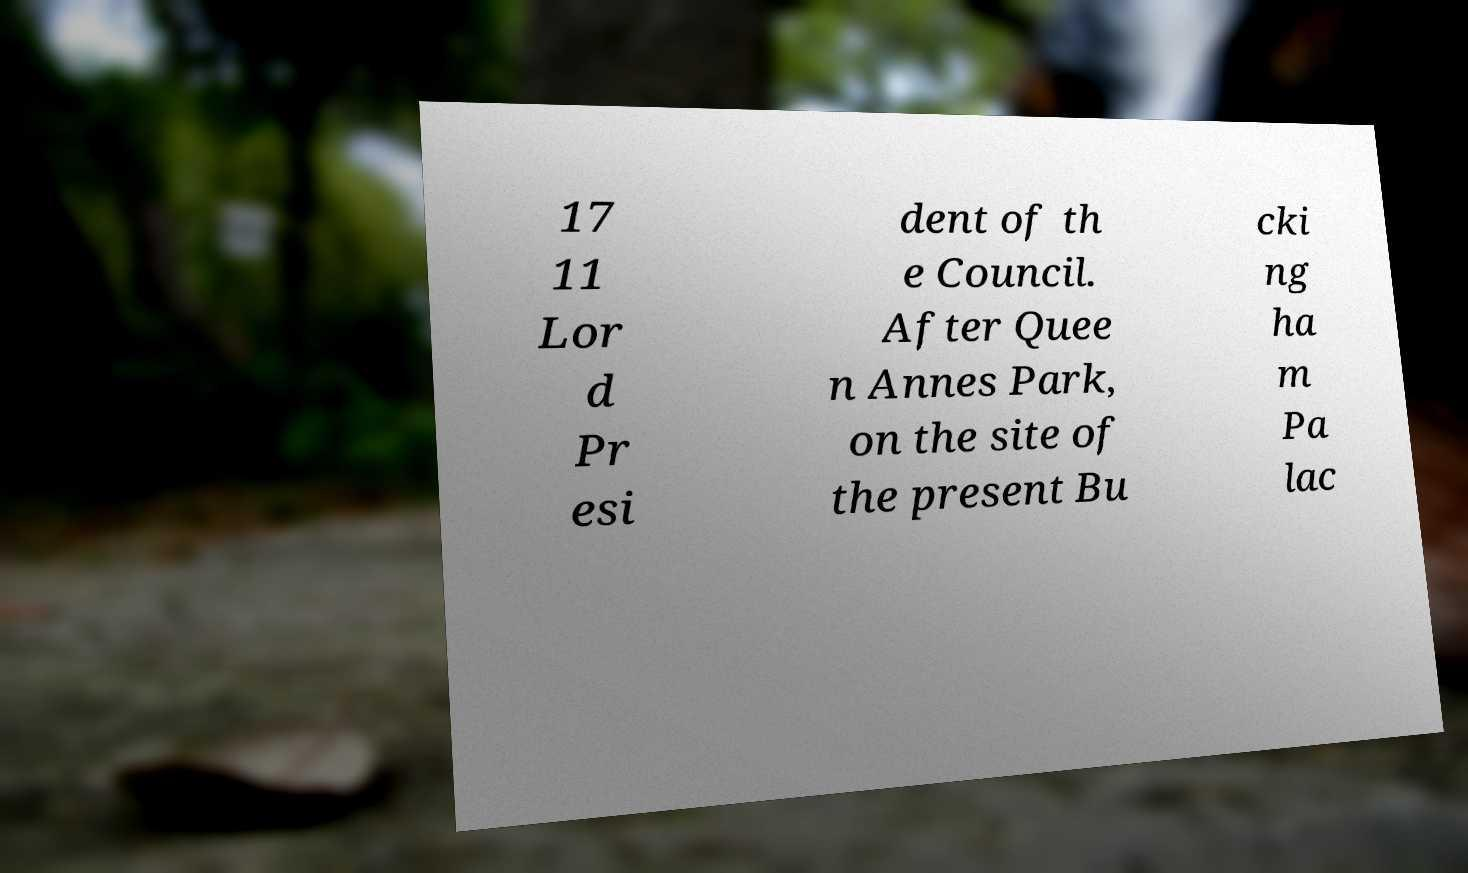There's text embedded in this image that I need extracted. Can you transcribe it verbatim? 17 11 Lor d Pr esi dent of th e Council. After Quee n Annes Park, on the site of the present Bu cki ng ha m Pa lac 